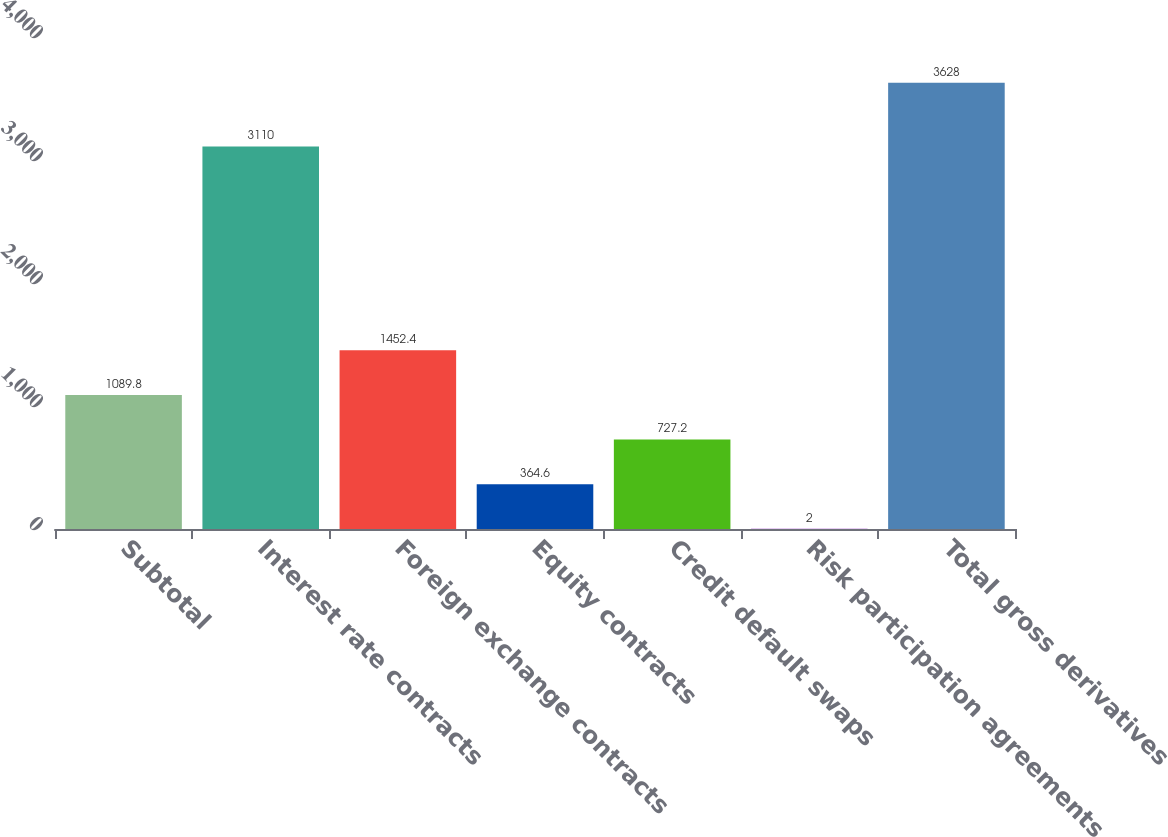<chart> <loc_0><loc_0><loc_500><loc_500><bar_chart><fcel>Subtotal<fcel>Interest rate contracts<fcel>Foreign exchange contracts<fcel>Equity contracts<fcel>Credit default swaps<fcel>Risk participation agreements<fcel>Total gross derivatives<nl><fcel>1089.8<fcel>3110<fcel>1452.4<fcel>364.6<fcel>727.2<fcel>2<fcel>3628<nl></chart> 